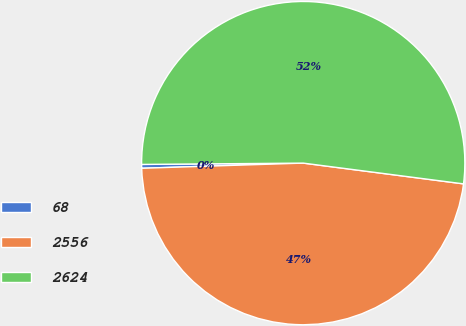Convert chart. <chart><loc_0><loc_0><loc_500><loc_500><pie_chart><fcel>68<fcel>2556<fcel>2624<nl><fcel>0.38%<fcel>47.44%<fcel>52.18%<nl></chart> 